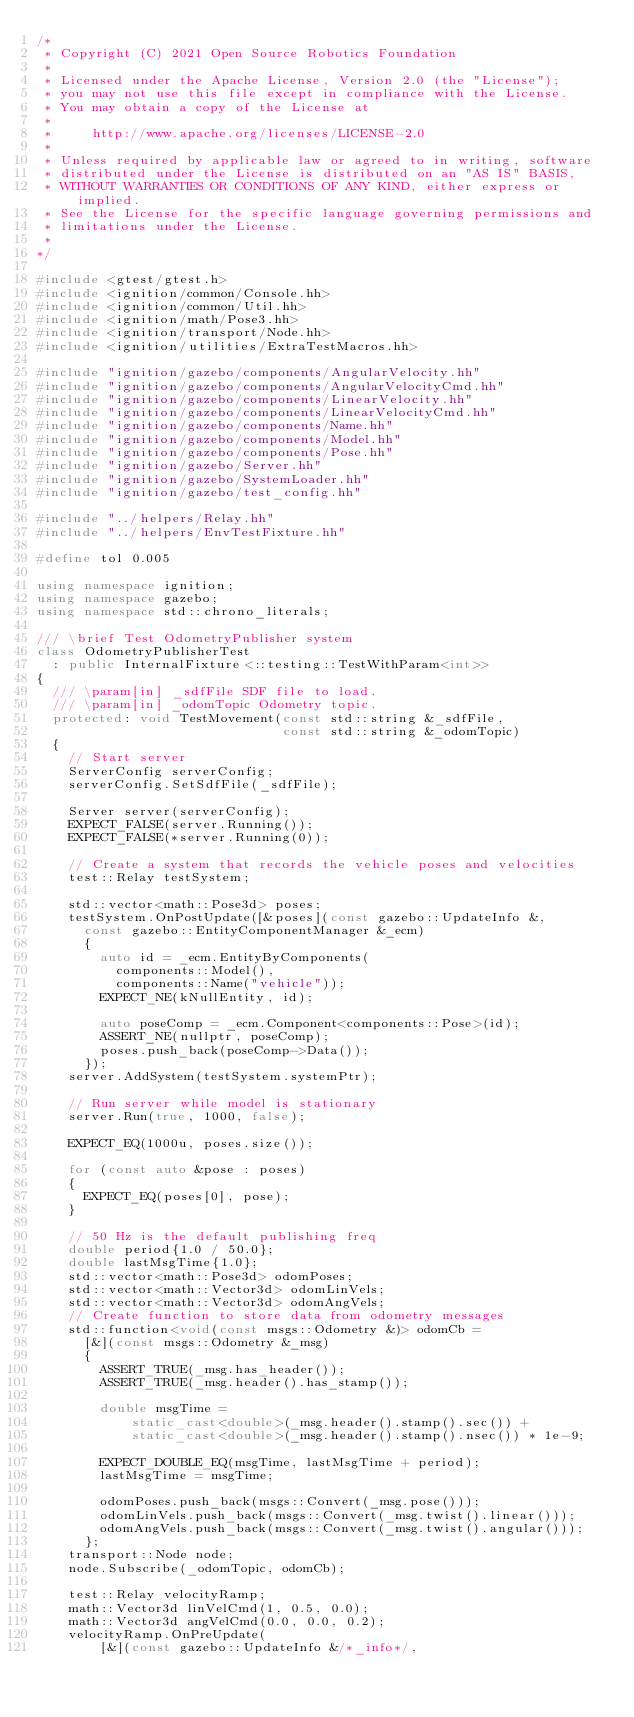<code> <loc_0><loc_0><loc_500><loc_500><_C++_>/*
 * Copyright (C) 2021 Open Source Robotics Foundation
 *
 * Licensed under the Apache License, Version 2.0 (the "License");
 * you may not use this file except in compliance with the License.
 * You may obtain a copy of the License at
 *
 *     http://www.apache.org/licenses/LICENSE-2.0
 *
 * Unless required by applicable law or agreed to in writing, software
 * distributed under the License is distributed on an "AS IS" BASIS,
 * WITHOUT WARRANTIES OR CONDITIONS OF ANY KIND, either express or implied.
 * See the License for the specific language governing permissions and
 * limitations under the License.
 *
*/

#include <gtest/gtest.h>
#include <ignition/common/Console.hh>
#include <ignition/common/Util.hh>
#include <ignition/math/Pose3.hh>
#include <ignition/transport/Node.hh>
#include <ignition/utilities/ExtraTestMacros.hh>

#include "ignition/gazebo/components/AngularVelocity.hh"
#include "ignition/gazebo/components/AngularVelocityCmd.hh"
#include "ignition/gazebo/components/LinearVelocity.hh"
#include "ignition/gazebo/components/LinearVelocityCmd.hh"
#include "ignition/gazebo/components/Name.hh"
#include "ignition/gazebo/components/Model.hh"
#include "ignition/gazebo/components/Pose.hh"
#include "ignition/gazebo/Server.hh"
#include "ignition/gazebo/SystemLoader.hh"
#include "ignition/gazebo/test_config.hh"

#include "../helpers/Relay.hh"
#include "../helpers/EnvTestFixture.hh"

#define tol 0.005

using namespace ignition;
using namespace gazebo;
using namespace std::chrono_literals;

/// \brief Test OdometryPublisher system
class OdometryPublisherTest
  : public InternalFixture<::testing::TestWithParam<int>>
{
  /// \param[in] _sdfFile SDF file to load.
  /// \param[in] _odomTopic Odometry topic.
  protected: void TestMovement(const std::string &_sdfFile,
                               const std::string &_odomTopic)
  {
    // Start server
    ServerConfig serverConfig;
    serverConfig.SetSdfFile(_sdfFile);

    Server server(serverConfig);
    EXPECT_FALSE(server.Running());
    EXPECT_FALSE(*server.Running(0));

    // Create a system that records the vehicle poses and velocities
    test::Relay testSystem;

    std::vector<math::Pose3d> poses;
    testSystem.OnPostUpdate([&poses](const gazebo::UpdateInfo &,
      const gazebo::EntityComponentManager &_ecm)
      {
        auto id = _ecm.EntityByComponents(
          components::Model(),
          components::Name("vehicle"));
        EXPECT_NE(kNullEntity, id);

        auto poseComp = _ecm.Component<components::Pose>(id);
        ASSERT_NE(nullptr, poseComp);
        poses.push_back(poseComp->Data());
      });
    server.AddSystem(testSystem.systemPtr);

    // Run server while model is stationary
    server.Run(true, 1000, false);

    EXPECT_EQ(1000u, poses.size());

    for (const auto &pose : poses)
    {
      EXPECT_EQ(poses[0], pose);
    }

    // 50 Hz is the default publishing freq
    double period{1.0 / 50.0};
    double lastMsgTime{1.0};
    std::vector<math::Pose3d> odomPoses;
    std::vector<math::Vector3d> odomLinVels;
    std::vector<math::Vector3d> odomAngVels;
    // Create function to store data from odometry messages
    std::function<void(const msgs::Odometry &)> odomCb =
      [&](const msgs::Odometry &_msg)
      {
        ASSERT_TRUE(_msg.has_header());
        ASSERT_TRUE(_msg.header().has_stamp());

        double msgTime =
            static_cast<double>(_msg.header().stamp().sec()) +
            static_cast<double>(_msg.header().stamp().nsec()) * 1e-9;

        EXPECT_DOUBLE_EQ(msgTime, lastMsgTime + period);
        lastMsgTime = msgTime;

        odomPoses.push_back(msgs::Convert(_msg.pose()));
        odomLinVels.push_back(msgs::Convert(_msg.twist().linear()));
        odomAngVels.push_back(msgs::Convert(_msg.twist().angular()));
      };
    transport::Node node;
    node.Subscribe(_odomTopic, odomCb);

    test::Relay velocityRamp;
    math::Vector3d linVelCmd(1, 0.5, 0.0);
    math::Vector3d angVelCmd(0.0, 0.0, 0.2);
    velocityRamp.OnPreUpdate(
        [&](const gazebo::UpdateInfo &/*_info*/,</code> 